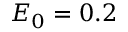Convert formula to latex. <formula><loc_0><loc_0><loc_500><loc_500>E _ { 0 } = 0 . 2</formula> 